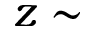<formula> <loc_0><loc_0><loc_500><loc_500>z \sim</formula> 